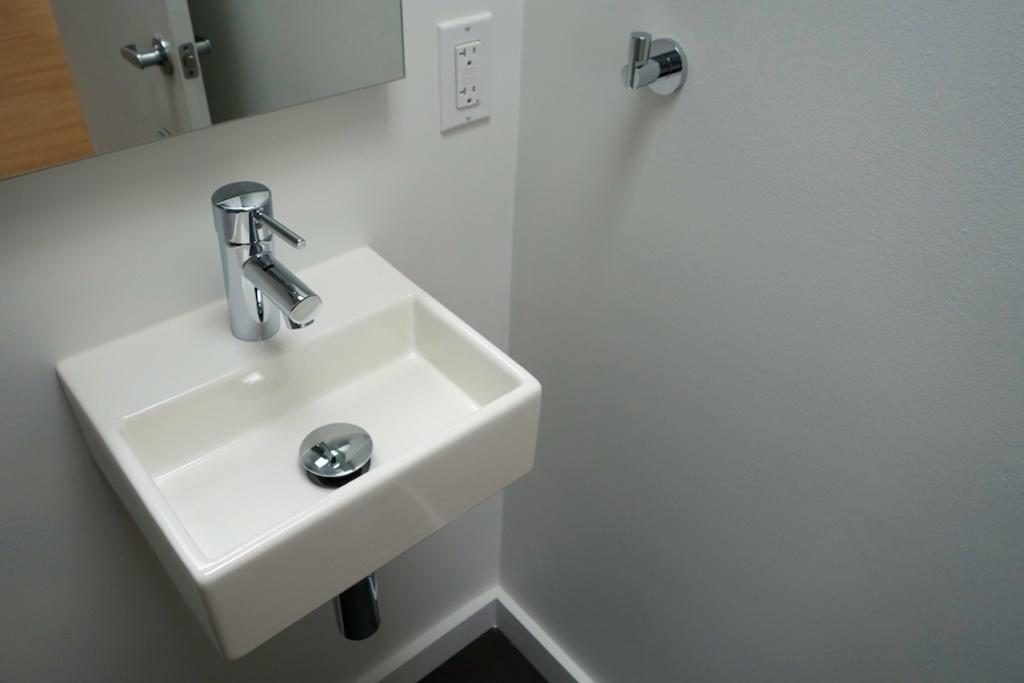What is the main object in the image? There is a wash basin in the image. What is attached to the wash basin? There is a tap in the image. What electrical component is present in the image? There is a socket in the image. What is the object in the image used for? The object in the image is not specified, but it could be a sink or basin for washing hands or other purposes. What is the background of the image made of? There is a wall in the image. What is used for personal grooming in the image? There is a mirror in the image. What can be seen in the reflection of the mirror? The reflection of a door and a holder are visible in the mirror. What type of powder is visible on the sticks in the image? There are no sticks or powder present in the image. How does the control panel in the image operate the lights? There is no control panel or lights present in the image. 